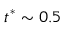<formula> <loc_0><loc_0><loc_500><loc_500>t ^ { * } \sim 0 . 5</formula> 